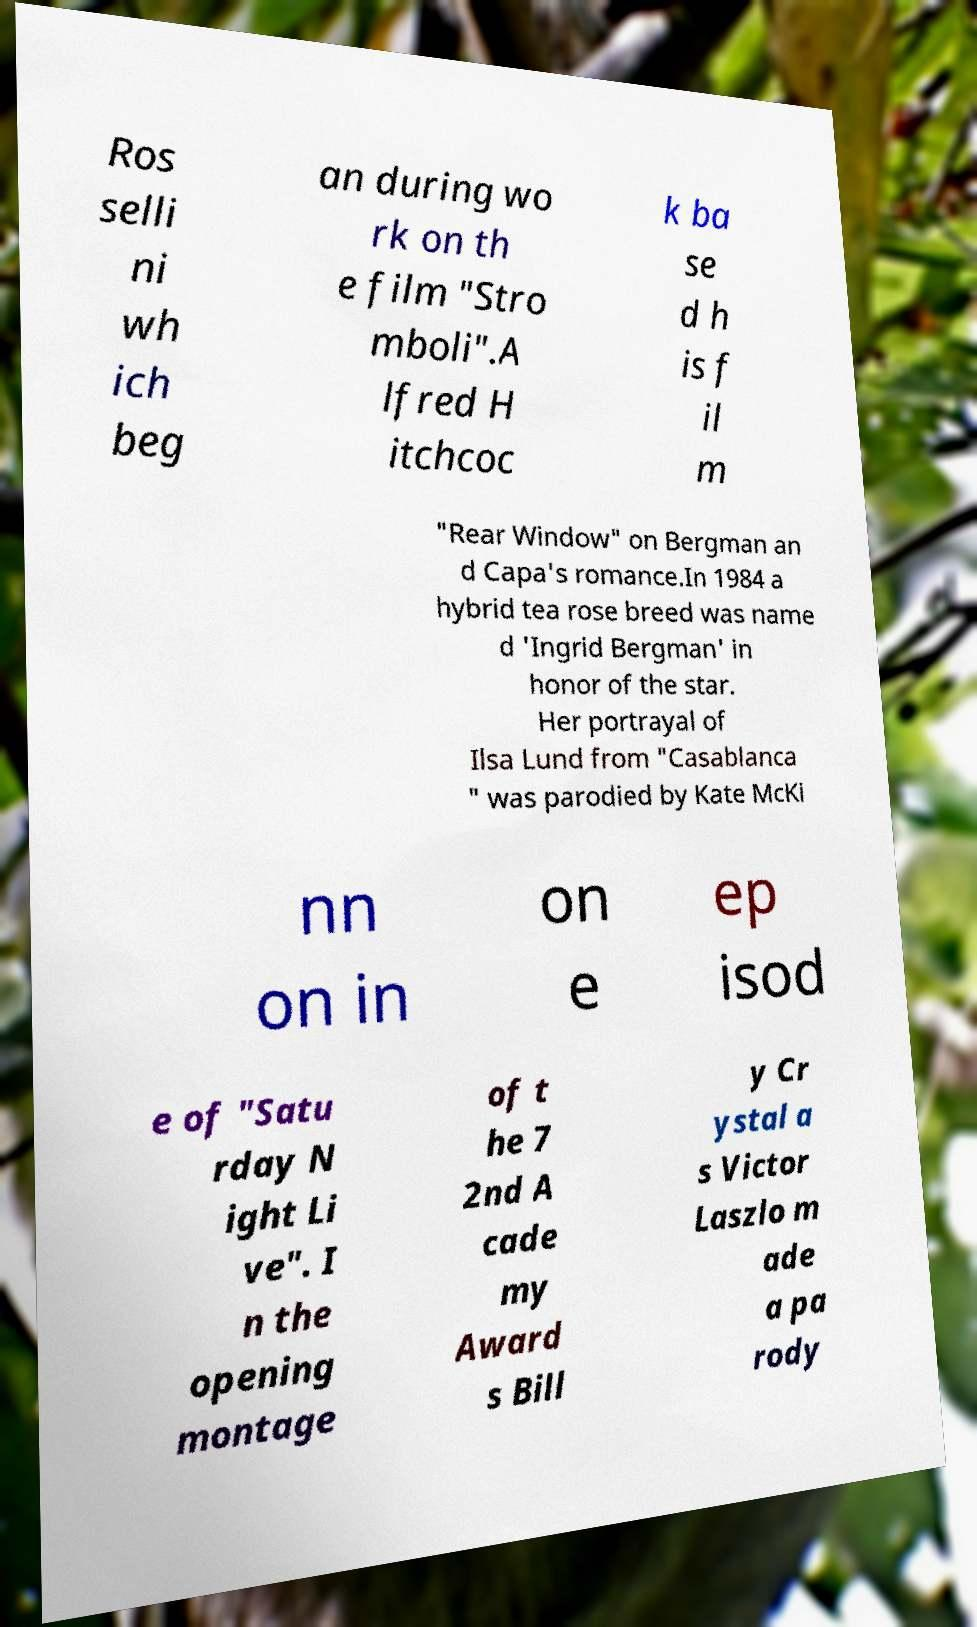There's text embedded in this image that I need extracted. Can you transcribe it verbatim? Ros selli ni wh ich beg an during wo rk on th e film "Stro mboli".A lfred H itchcoc k ba se d h is f il m "Rear Window" on Bergman an d Capa's romance.In 1984 a hybrid tea rose breed was name d 'Ingrid Bergman' in honor of the star. Her portrayal of Ilsa Lund from "Casablanca " was parodied by Kate McKi nn on in on e ep isod e of "Satu rday N ight Li ve". I n the opening montage of t he 7 2nd A cade my Award s Bill y Cr ystal a s Victor Laszlo m ade a pa rody 